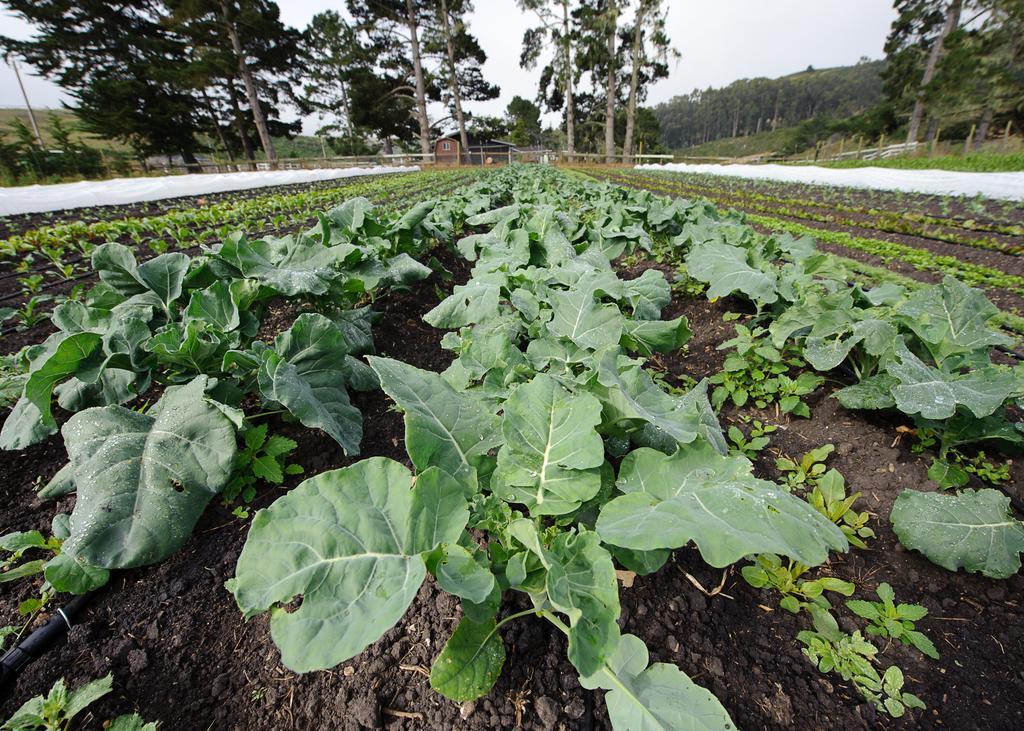Please provide a concise description of this image. In this picture, we see the green plants in the field. At the bottom, we see the black soil. On either side of the picture, we see the white color cloth. Beside that, we see the wooden fence. There are trees in the background. At the top, we see the sky. 